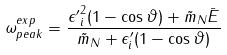<formula> <loc_0><loc_0><loc_500><loc_500>\omega _ { p e a k } ^ { e x p } = \frac { { \epsilon ^ { \prime } } _ { i } ^ { 2 } ( 1 - \cos \vartheta ) + \tilde { m } _ { N } \bar { E } } { \tilde { m } _ { N } + \epsilon ^ { \prime } _ { i } ( 1 - \cos \vartheta ) }</formula> 